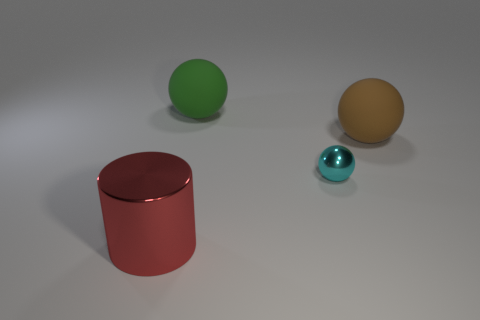Is there a size difference among the objects in the image? Yes, there are noticeable size differences among the objects. The red cylinder is the largest, followed by the green and yellow spheres. The cyan object is the smallest or, perhaps more accurately, the furthest from the viewpoint, which accentuates its smaller appearance in perspective. 